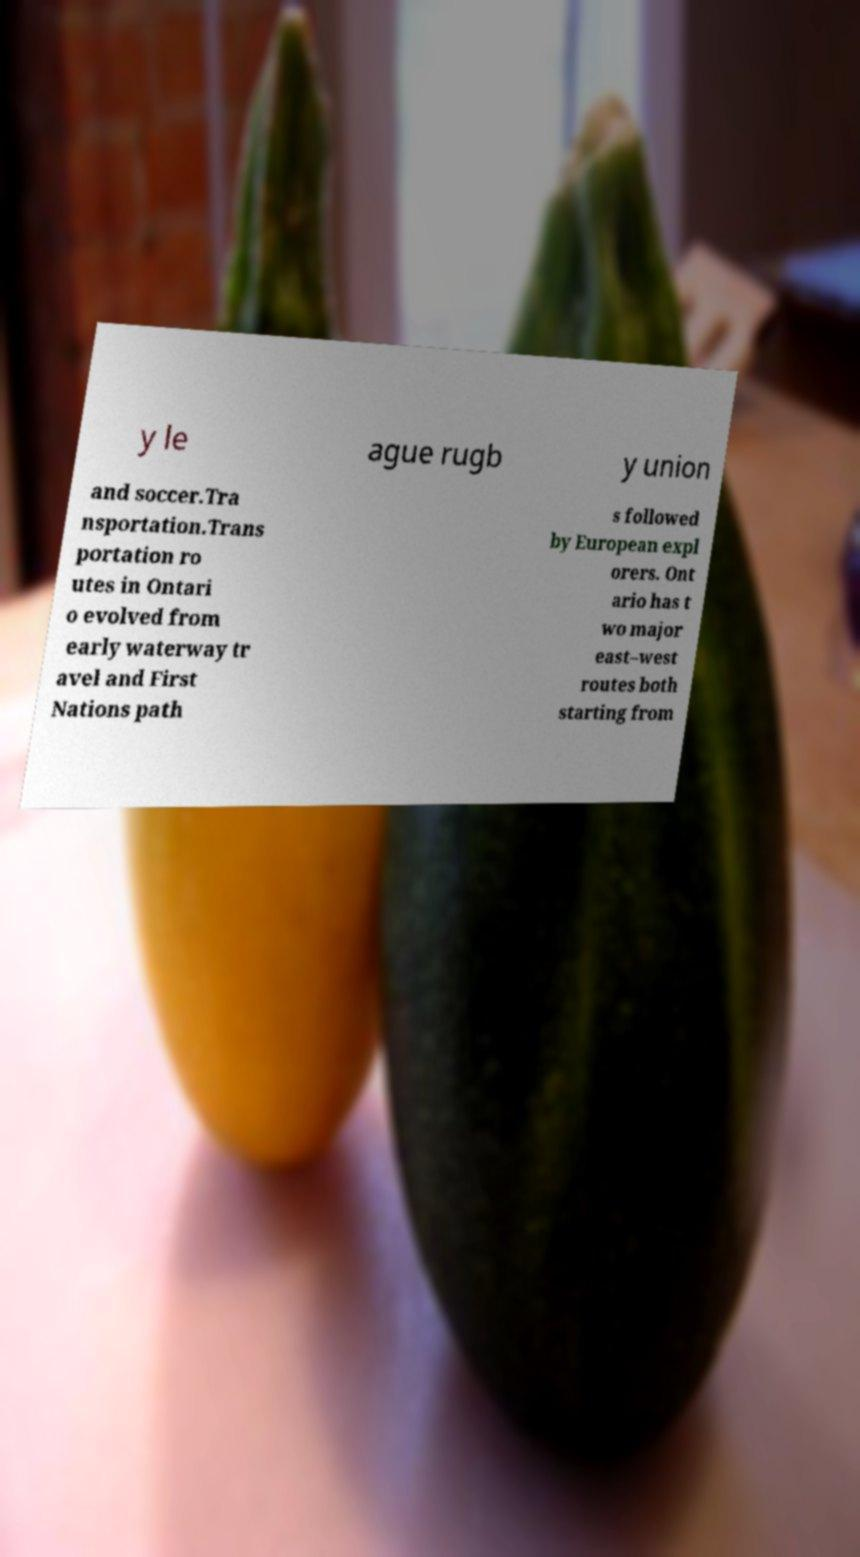Could you assist in decoding the text presented in this image and type it out clearly? y le ague rugb y union and soccer.Tra nsportation.Trans portation ro utes in Ontari o evolved from early waterway tr avel and First Nations path s followed by European expl orers. Ont ario has t wo major east–west routes both starting from 